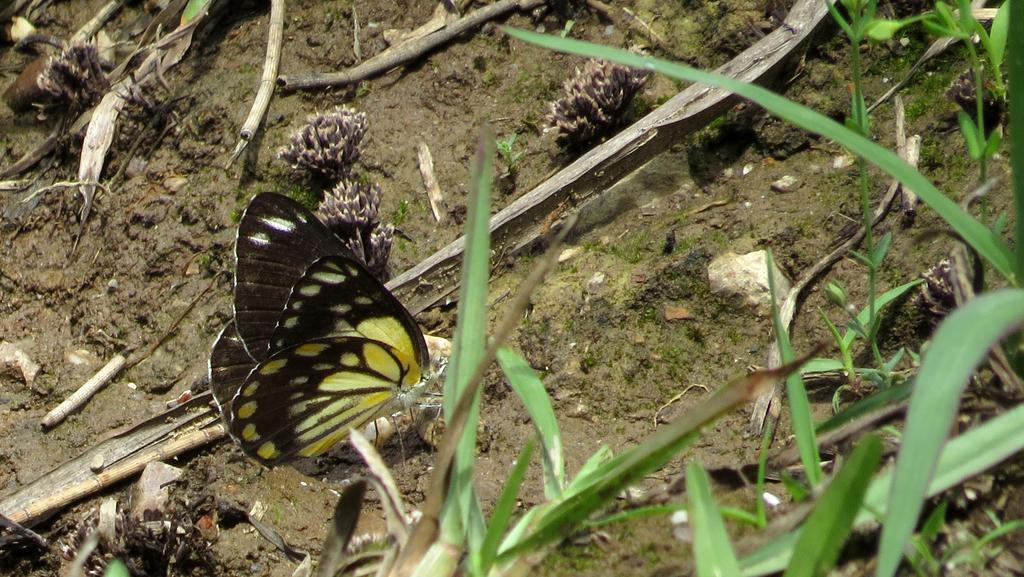What can be seen in the foreground of the image? There are leaves and a butterfly in the foreground of the image. What is visible in the background of the image? There are flowers and dry stems in the background of the image. Where is the watch located in the image? There is no watch present in the image. What type of sofa can be seen in the background of the image? There is no sofa present in the image. 